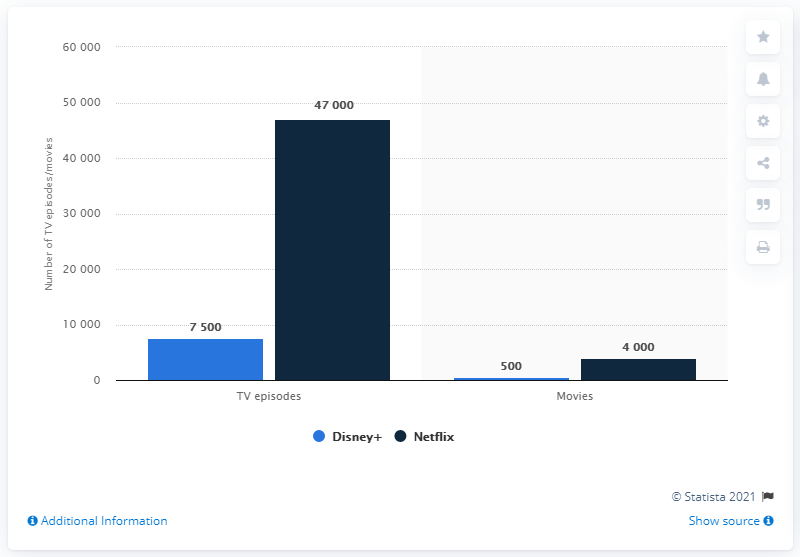List a handful of essential elements in this visual. Disney+ currently has 47,000 episodes in its U.S. catalog. The difference between the highest and the lowest bar value of Netflix is 43000. I declare that Disney+ is expected to have 500 movies. The difference between the shortest light blue bar and the tallest dark blue bar is -4,650. 